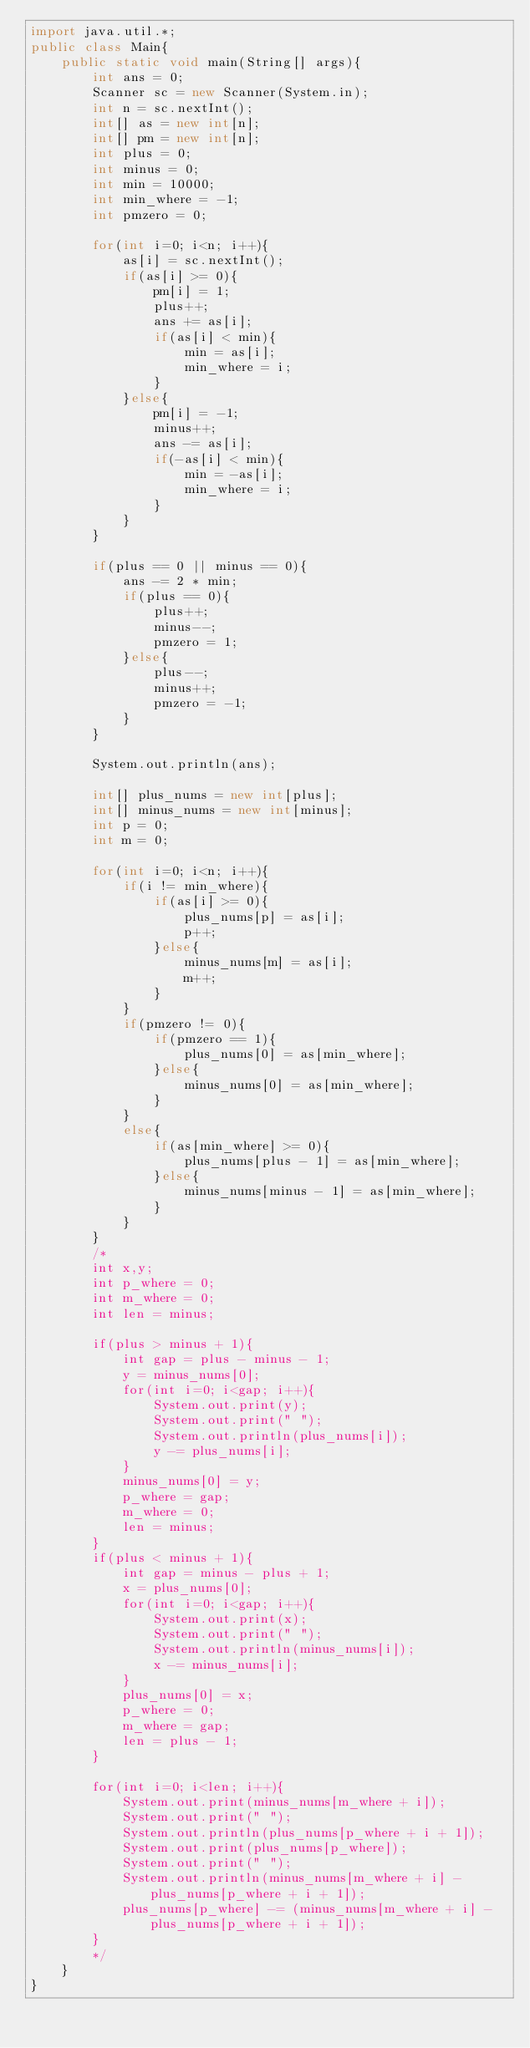Convert code to text. <code><loc_0><loc_0><loc_500><loc_500><_Java_>import java.util.*;
public class Main{
	public static void main(String[] args){
		int ans = 0;
		Scanner sc = new Scanner(System.in);
		int n = sc.nextInt();
		int[] as = new int[n];
		int[] pm = new int[n];
		int plus = 0;
		int minus = 0;
		int min = 10000;
		int min_where = -1;
		int pmzero = 0;
		
		for(int i=0; i<n; i++){
			as[i] = sc.nextInt();
			if(as[i] >= 0){
				pm[i] = 1;
				plus++;
				ans += as[i];
				if(as[i] < min){
					min = as[i];
					min_where = i;
				}
			}else{
				pm[i] = -1;
				minus++;
				ans -= as[i];
				if(-as[i] < min){
					min = -as[i];
					min_where = i;
				}
			}
		}
		
		if(plus == 0 || minus == 0){
			ans -= 2 * min;
			if(plus == 0){
				plus++;
				minus--;
				pmzero = 1;
			}else{
				plus--;
				minus++;
				pmzero = -1;
			}
		}
		
		System.out.println(ans);
		
		int[] plus_nums = new int[plus];
		int[] minus_nums = new int[minus];
		int p = 0;
		int m = 0;
		
		for(int i=0; i<n; i++){
			if(i != min_where){
				if(as[i] >= 0){
					plus_nums[p] = as[i];
					p++;
				}else{
					minus_nums[m] = as[i];
					m++;
				}
			}
			if(pmzero != 0){
				if(pmzero == 1){
					plus_nums[0] = as[min_where];
				}else{
					minus_nums[0] = as[min_where];
				}
			}
			else{
				if(as[min_where] >= 0){
					plus_nums[plus - 1] = as[min_where];
				}else{
					minus_nums[minus - 1] = as[min_where];
				}
			}
		}
		/*
		int x,y;
		int p_where = 0;
		int m_where = 0;
		int len = minus;
		
		if(plus > minus + 1){
			int gap = plus - minus - 1;
			y = minus_nums[0];
			for(int i=0; i<gap; i++){
				System.out.print(y);
				System.out.print(" ");
				System.out.println(plus_nums[i]);
				y -= plus_nums[i];
			}
			minus_nums[0] = y;
			p_where = gap;
			m_where = 0;
			len = minus;
		}
		if(plus < minus + 1){
			int gap = minus - plus + 1;
			x = plus_nums[0];
			for(int i=0; i<gap; i++){
				System.out.print(x);
				System.out.print(" ");
				System.out.println(minus_nums[i]);
				x -= minus_nums[i];
			}
			plus_nums[0] = x;
			p_where = 0;
			m_where = gap;
			len = plus - 1;
		}
		
		for(int i=0; i<len; i++){
			System.out.print(minus_nums[m_where + i]);
			System.out.print(" ");
			System.out.println(plus_nums[p_where + i + 1]);
			System.out.print(plus_nums[p_where]);
			System.out.print(" ");
			System.out.println(minus_nums[m_where + i] - plus_nums[p_where + i + 1]);
			plus_nums[p_where] -= (minus_nums[m_where + i] - plus_nums[p_where + i + 1]);
		}
		*/
	}
}
</code> 